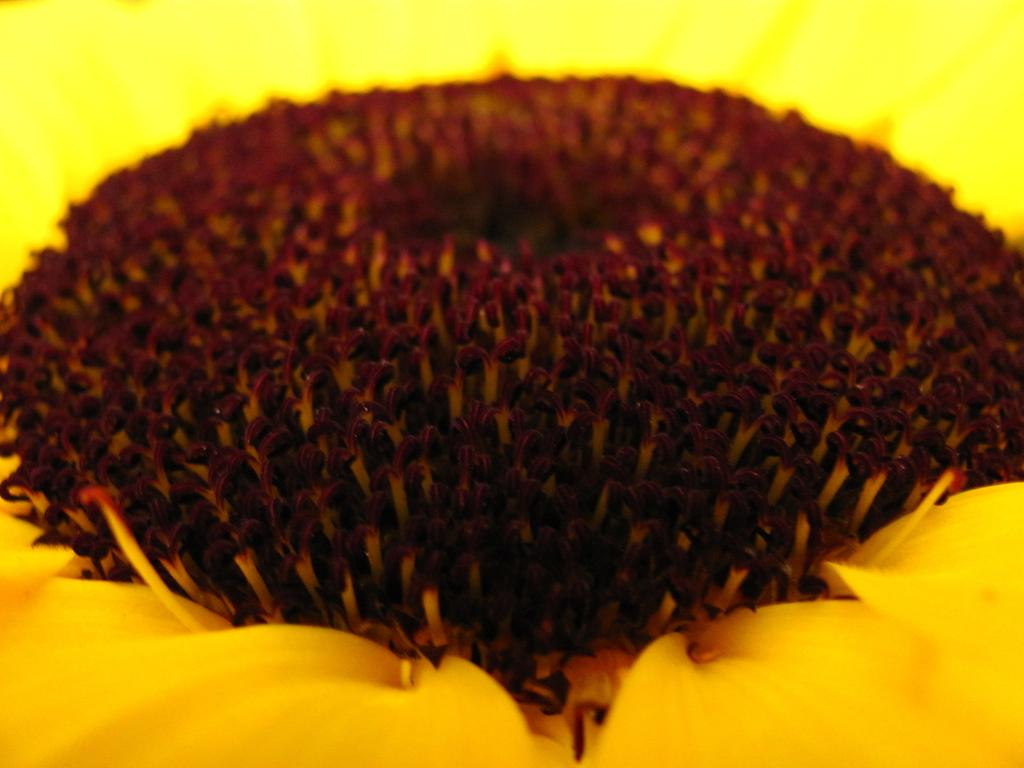What type of flower is present in the image? There is a yellow flower in the image. Can you describe the structure of the flower? The flower has disk florets in the middle. What type of trains can be seen passing by the flower in the image? There are no trains present in the image; it only features a yellow flower with disk florets in the middle. 